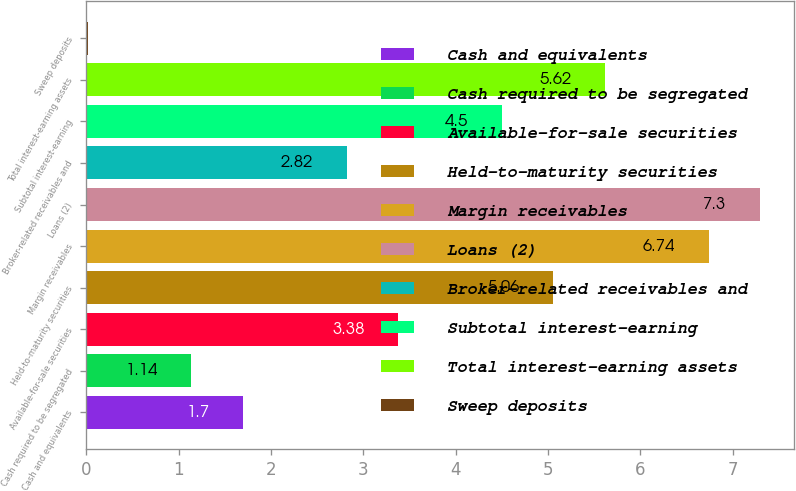Convert chart to OTSL. <chart><loc_0><loc_0><loc_500><loc_500><bar_chart><fcel>Cash and equivalents<fcel>Cash required to be segregated<fcel>Available-for-sale securities<fcel>Held-to-maturity securities<fcel>Margin receivables<fcel>Loans (2)<fcel>Broker-related receivables and<fcel>Subtotal interest-earning<fcel>Total interest-earning assets<fcel>Sweep deposits<nl><fcel>1.7<fcel>1.14<fcel>3.38<fcel>5.06<fcel>6.74<fcel>7.3<fcel>2.82<fcel>4.5<fcel>5.62<fcel>0.02<nl></chart> 